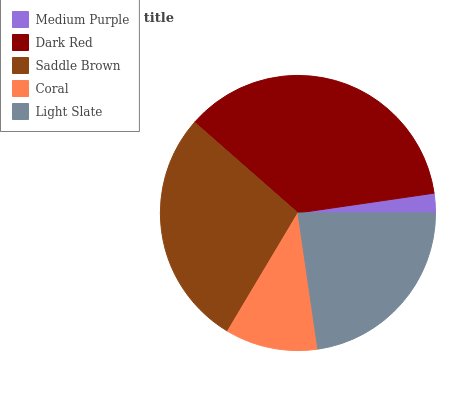Is Medium Purple the minimum?
Answer yes or no. Yes. Is Dark Red the maximum?
Answer yes or no. Yes. Is Saddle Brown the minimum?
Answer yes or no. No. Is Saddle Brown the maximum?
Answer yes or no. No. Is Dark Red greater than Saddle Brown?
Answer yes or no. Yes. Is Saddle Brown less than Dark Red?
Answer yes or no. Yes. Is Saddle Brown greater than Dark Red?
Answer yes or no. No. Is Dark Red less than Saddle Brown?
Answer yes or no. No. Is Light Slate the high median?
Answer yes or no. Yes. Is Light Slate the low median?
Answer yes or no. Yes. Is Medium Purple the high median?
Answer yes or no. No. Is Dark Red the low median?
Answer yes or no. No. 